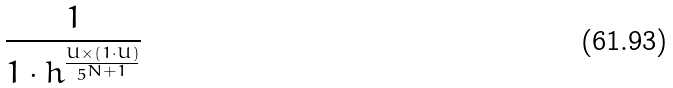<formula> <loc_0><loc_0><loc_500><loc_500>\frac { 1 } { 1 \cdot h ^ { \frac { U \times ( 1 \cdot U ) } { 5 ^ { N + 1 } } } }</formula> 